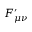Convert formula to latex. <formula><loc_0><loc_0><loc_500><loc_500>F _ { \mu \nu } ^ { \prime }</formula> 